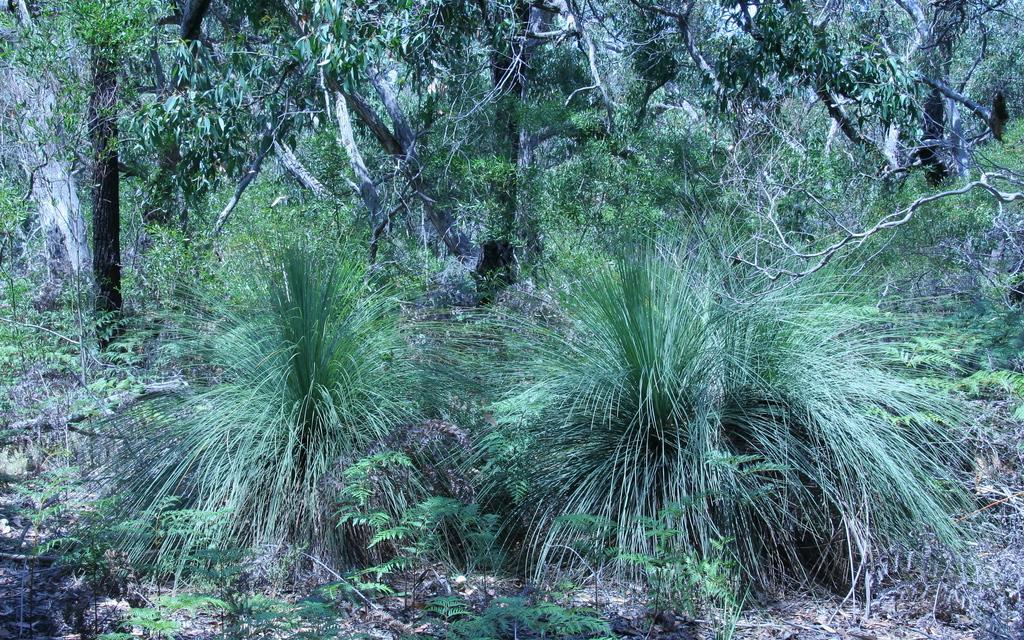In one or two sentences, can you explain what this image depicts? In the picture I can see plants and trees. I can also see the grass. 